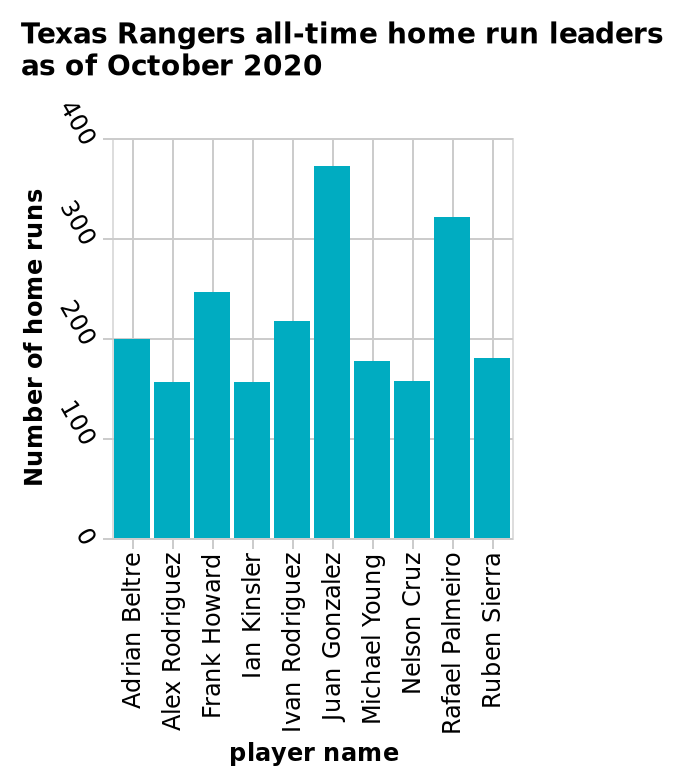<image>
What is the subject of the bar graph? Texas Rangers all-time home run leaders Who has the highest number of home runs?  Juan Gonzales 